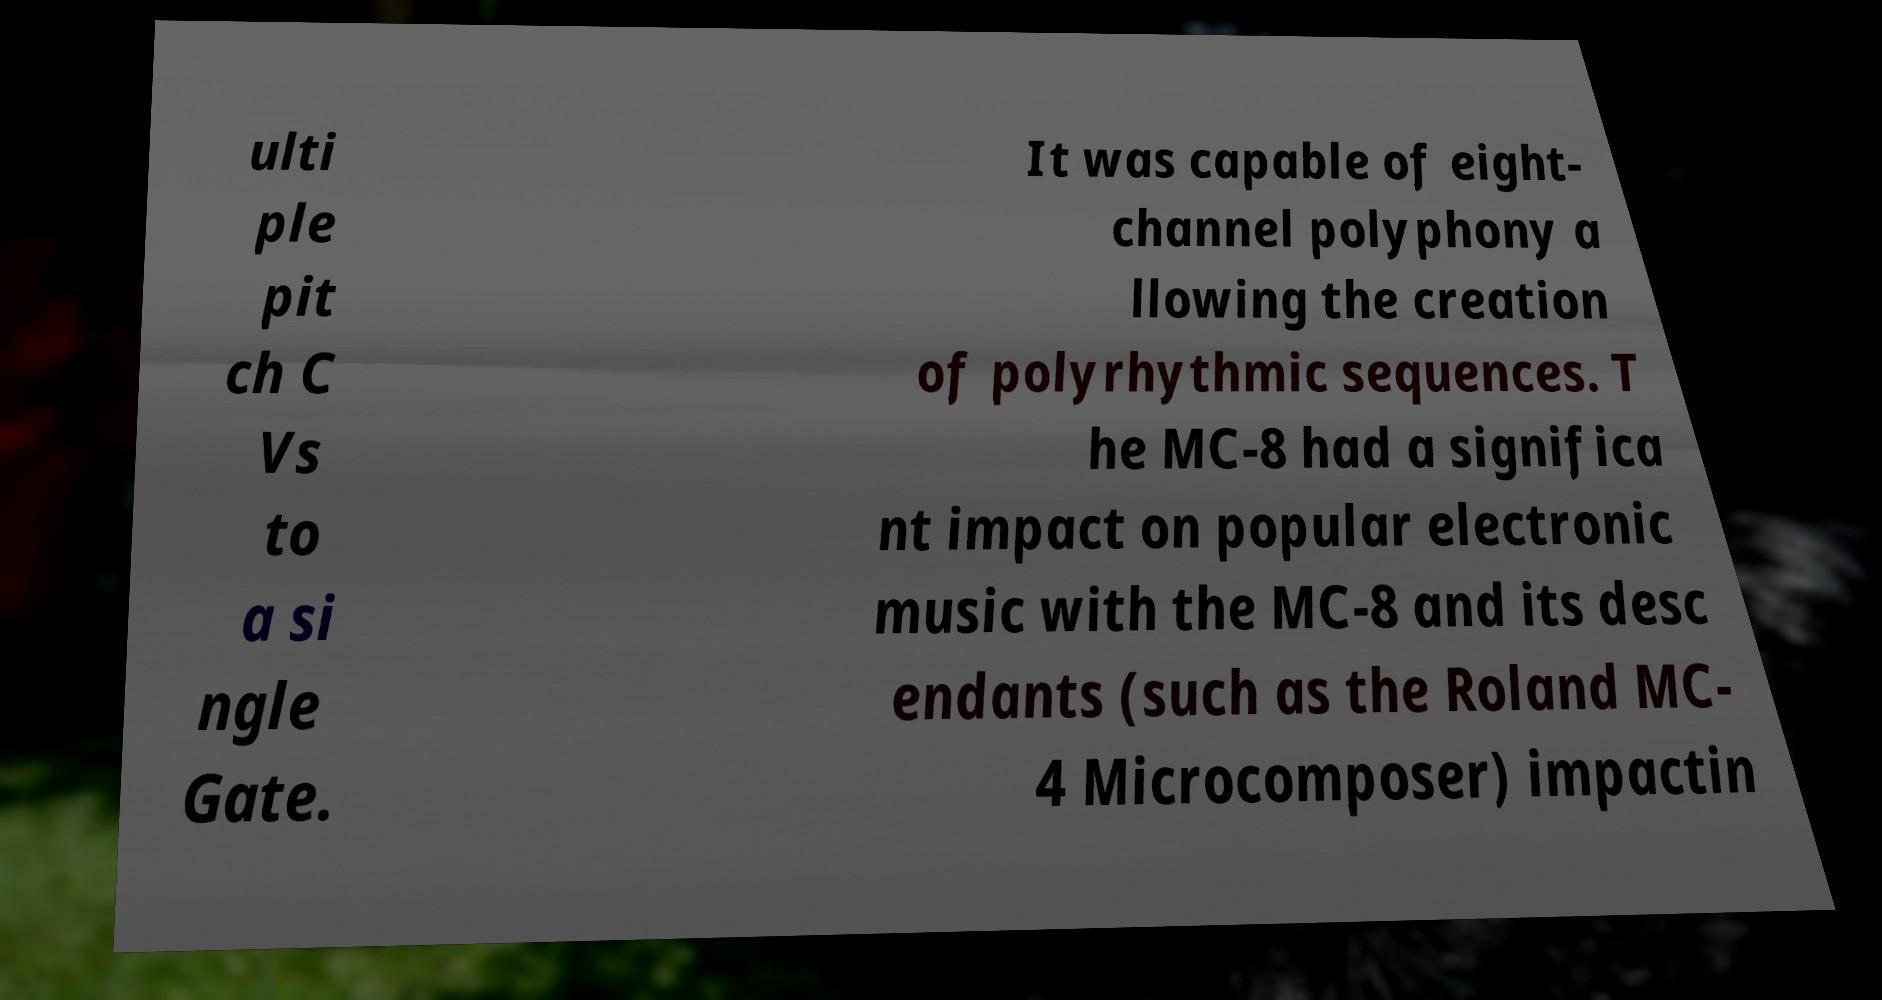Please identify and transcribe the text found in this image. ulti ple pit ch C Vs to a si ngle Gate. It was capable of eight- channel polyphony a llowing the creation of polyrhythmic sequences. T he MC-8 had a significa nt impact on popular electronic music with the MC-8 and its desc endants (such as the Roland MC- 4 Microcomposer) impactin 